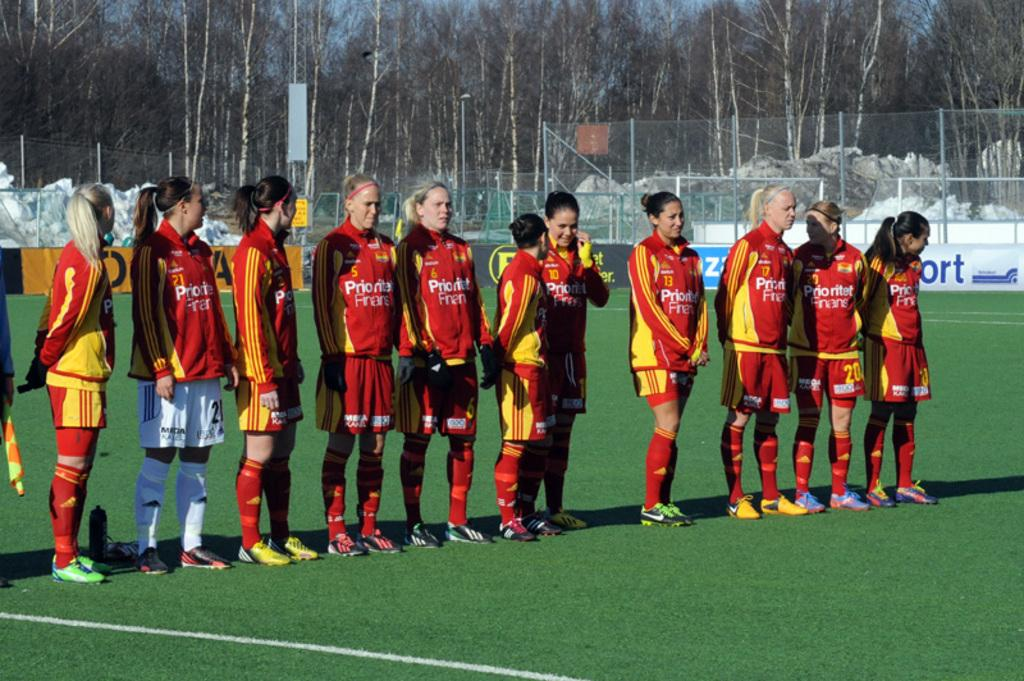What are the people in the image doing? The people in the image are standing on the ground. What can be seen in the background behind the people? Trees are visible behind the people in the image. What type of barrier is present in the image? Fences are present in the image. What part of the sky is visible in the image? The sky is visible in the image. What type of box is being used to store the dolls in the image? There is no box or dolls present in the image. 